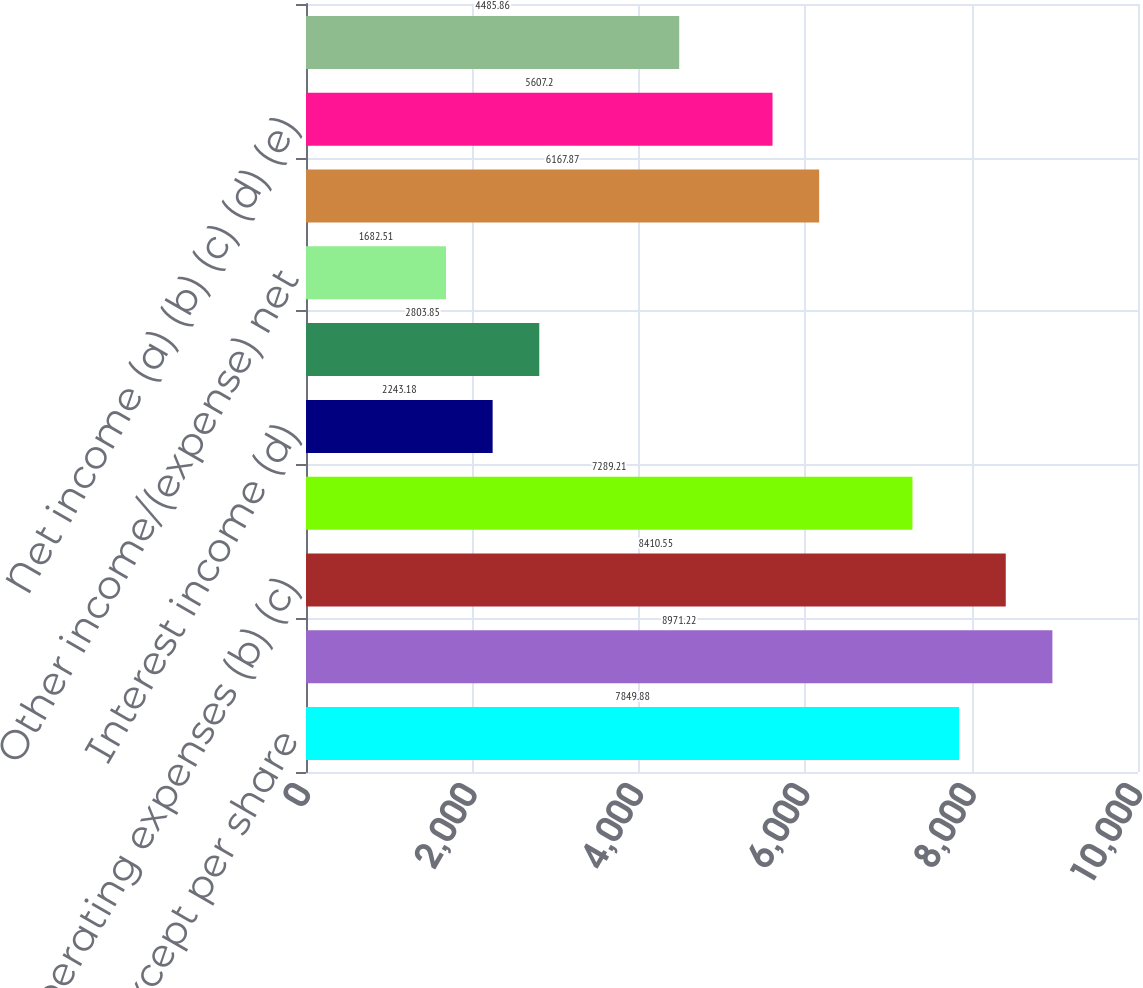Convert chart to OTSL. <chart><loc_0><loc_0><loc_500><loc_500><bar_chart><fcel>(in millions except per share<fcel>Revenues (a)<fcel>Operating expenses (b) (c)<fcel>Operating income (a) (b) (c)<fcel>Interest income (d)<fcel>Interest expense (e)<fcel>Other income/(expense) net<fcel>Income before income taxes (a)<fcel>Net income (a) (b) (c) (d) (e)<fcel>Depreciation and amortization<nl><fcel>7849.88<fcel>8971.22<fcel>8410.55<fcel>7289.21<fcel>2243.18<fcel>2803.85<fcel>1682.51<fcel>6167.87<fcel>5607.2<fcel>4485.86<nl></chart> 